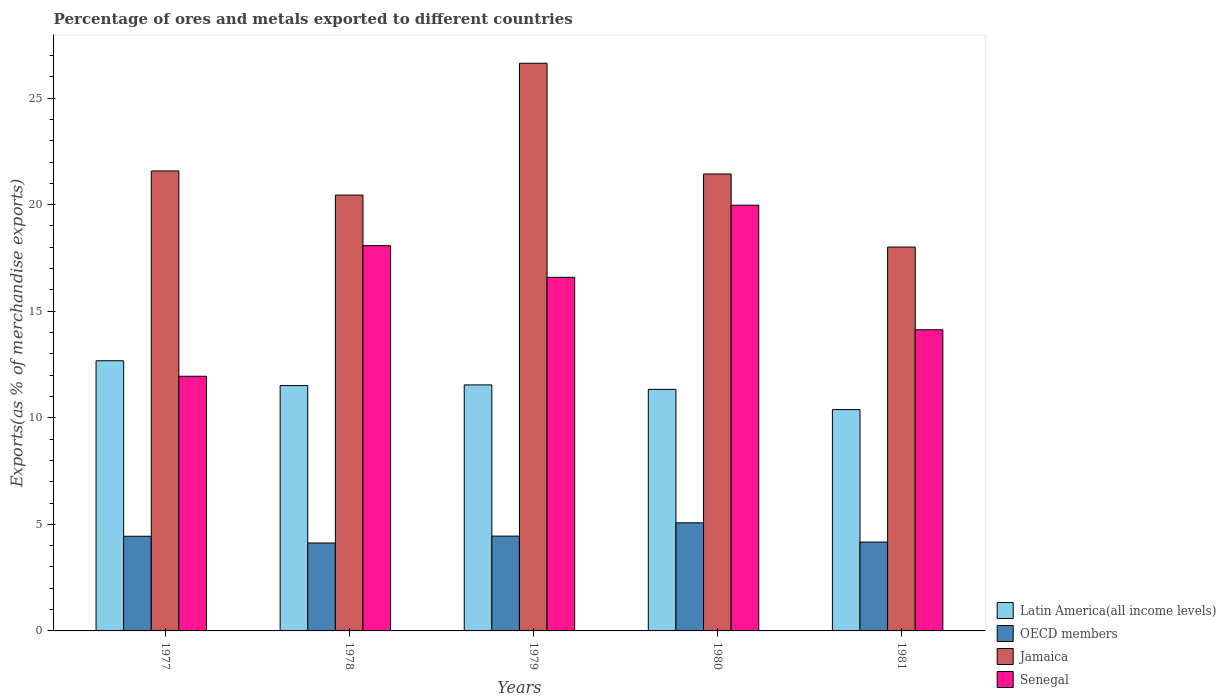Are the number of bars per tick equal to the number of legend labels?
Your response must be concise. Yes. What is the label of the 5th group of bars from the left?
Offer a terse response. 1981. In how many cases, is the number of bars for a given year not equal to the number of legend labels?
Provide a short and direct response. 0. What is the percentage of exports to different countries in Latin America(all income levels) in 1980?
Keep it short and to the point. 11.33. Across all years, what is the maximum percentage of exports to different countries in Senegal?
Your answer should be very brief. 19.97. Across all years, what is the minimum percentage of exports to different countries in Jamaica?
Keep it short and to the point. 18.01. In which year was the percentage of exports to different countries in Senegal maximum?
Your answer should be very brief. 1980. In which year was the percentage of exports to different countries in Senegal minimum?
Ensure brevity in your answer.  1977. What is the total percentage of exports to different countries in Latin America(all income levels) in the graph?
Give a very brief answer. 57.45. What is the difference between the percentage of exports to different countries in Senegal in 1977 and that in 1978?
Your answer should be very brief. -6.13. What is the difference between the percentage of exports to different countries in Jamaica in 1981 and the percentage of exports to different countries in Senegal in 1979?
Give a very brief answer. 1.42. What is the average percentage of exports to different countries in Jamaica per year?
Make the answer very short. 21.62. In the year 1978, what is the difference between the percentage of exports to different countries in Jamaica and percentage of exports to different countries in Senegal?
Offer a very short reply. 2.37. In how many years, is the percentage of exports to different countries in Latin America(all income levels) greater than 10 %?
Make the answer very short. 5. What is the ratio of the percentage of exports to different countries in Senegal in 1977 to that in 1980?
Your response must be concise. 0.6. What is the difference between the highest and the second highest percentage of exports to different countries in OECD members?
Give a very brief answer. 0.62. What is the difference between the highest and the lowest percentage of exports to different countries in Jamaica?
Keep it short and to the point. 8.62. Is it the case that in every year, the sum of the percentage of exports to different countries in Senegal and percentage of exports to different countries in OECD members is greater than the sum of percentage of exports to different countries in Latin America(all income levels) and percentage of exports to different countries in Jamaica?
Provide a short and direct response. No. What does the 1st bar from the left in 1979 represents?
Provide a short and direct response. Latin America(all income levels). What does the 4th bar from the right in 1980 represents?
Keep it short and to the point. Latin America(all income levels). How many bars are there?
Your answer should be compact. 20. Are all the bars in the graph horizontal?
Your answer should be compact. No. How many years are there in the graph?
Your answer should be compact. 5. Are the values on the major ticks of Y-axis written in scientific E-notation?
Give a very brief answer. No. Where does the legend appear in the graph?
Provide a short and direct response. Bottom right. How many legend labels are there?
Provide a succinct answer. 4. How are the legend labels stacked?
Make the answer very short. Vertical. What is the title of the graph?
Ensure brevity in your answer.  Percentage of ores and metals exported to different countries. What is the label or title of the X-axis?
Provide a short and direct response. Years. What is the label or title of the Y-axis?
Provide a short and direct response. Exports(as % of merchandise exports). What is the Exports(as % of merchandise exports) of Latin America(all income levels) in 1977?
Ensure brevity in your answer.  12.68. What is the Exports(as % of merchandise exports) of OECD members in 1977?
Make the answer very short. 4.44. What is the Exports(as % of merchandise exports) in Jamaica in 1977?
Keep it short and to the point. 21.58. What is the Exports(as % of merchandise exports) of Senegal in 1977?
Give a very brief answer. 11.95. What is the Exports(as % of merchandise exports) in Latin America(all income levels) in 1978?
Keep it short and to the point. 11.51. What is the Exports(as % of merchandise exports) in OECD members in 1978?
Give a very brief answer. 4.13. What is the Exports(as % of merchandise exports) in Jamaica in 1978?
Offer a terse response. 20.45. What is the Exports(as % of merchandise exports) of Senegal in 1978?
Your answer should be very brief. 18.08. What is the Exports(as % of merchandise exports) of Latin America(all income levels) in 1979?
Offer a very short reply. 11.54. What is the Exports(as % of merchandise exports) of OECD members in 1979?
Give a very brief answer. 4.45. What is the Exports(as % of merchandise exports) in Jamaica in 1979?
Offer a very short reply. 26.63. What is the Exports(as % of merchandise exports) of Senegal in 1979?
Your answer should be very brief. 16.59. What is the Exports(as % of merchandise exports) in Latin America(all income levels) in 1980?
Your response must be concise. 11.33. What is the Exports(as % of merchandise exports) of OECD members in 1980?
Ensure brevity in your answer.  5.07. What is the Exports(as % of merchandise exports) in Jamaica in 1980?
Provide a succinct answer. 21.44. What is the Exports(as % of merchandise exports) of Senegal in 1980?
Your response must be concise. 19.97. What is the Exports(as % of merchandise exports) in Latin America(all income levels) in 1981?
Make the answer very short. 10.38. What is the Exports(as % of merchandise exports) of OECD members in 1981?
Your response must be concise. 4.17. What is the Exports(as % of merchandise exports) in Jamaica in 1981?
Your response must be concise. 18.01. What is the Exports(as % of merchandise exports) in Senegal in 1981?
Offer a very short reply. 14.13. Across all years, what is the maximum Exports(as % of merchandise exports) in Latin America(all income levels)?
Make the answer very short. 12.68. Across all years, what is the maximum Exports(as % of merchandise exports) in OECD members?
Offer a very short reply. 5.07. Across all years, what is the maximum Exports(as % of merchandise exports) of Jamaica?
Offer a very short reply. 26.63. Across all years, what is the maximum Exports(as % of merchandise exports) of Senegal?
Your response must be concise. 19.97. Across all years, what is the minimum Exports(as % of merchandise exports) in Latin America(all income levels)?
Ensure brevity in your answer.  10.38. Across all years, what is the minimum Exports(as % of merchandise exports) of OECD members?
Make the answer very short. 4.13. Across all years, what is the minimum Exports(as % of merchandise exports) in Jamaica?
Offer a very short reply. 18.01. Across all years, what is the minimum Exports(as % of merchandise exports) in Senegal?
Your answer should be compact. 11.95. What is the total Exports(as % of merchandise exports) in Latin America(all income levels) in the graph?
Your answer should be very brief. 57.45. What is the total Exports(as % of merchandise exports) of OECD members in the graph?
Your answer should be very brief. 22.26. What is the total Exports(as % of merchandise exports) of Jamaica in the graph?
Your answer should be compact. 108.12. What is the total Exports(as % of merchandise exports) in Senegal in the graph?
Offer a very short reply. 80.72. What is the difference between the Exports(as % of merchandise exports) in Latin America(all income levels) in 1977 and that in 1978?
Keep it short and to the point. 1.16. What is the difference between the Exports(as % of merchandise exports) of OECD members in 1977 and that in 1978?
Keep it short and to the point. 0.32. What is the difference between the Exports(as % of merchandise exports) in Jamaica in 1977 and that in 1978?
Keep it short and to the point. 1.13. What is the difference between the Exports(as % of merchandise exports) of Senegal in 1977 and that in 1978?
Your answer should be compact. -6.13. What is the difference between the Exports(as % of merchandise exports) in Latin America(all income levels) in 1977 and that in 1979?
Ensure brevity in your answer.  1.13. What is the difference between the Exports(as % of merchandise exports) of OECD members in 1977 and that in 1979?
Your answer should be very brief. -0.01. What is the difference between the Exports(as % of merchandise exports) in Jamaica in 1977 and that in 1979?
Keep it short and to the point. -5.05. What is the difference between the Exports(as % of merchandise exports) of Senegal in 1977 and that in 1979?
Offer a terse response. -4.64. What is the difference between the Exports(as % of merchandise exports) in Latin America(all income levels) in 1977 and that in 1980?
Keep it short and to the point. 1.34. What is the difference between the Exports(as % of merchandise exports) of OECD members in 1977 and that in 1980?
Provide a succinct answer. -0.63. What is the difference between the Exports(as % of merchandise exports) in Jamaica in 1977 and that in 1980?
Provide a short and direct response. 0.14. What is the difference between the Exports(as % of merchandise exports) in Senegal in 1977 and that in 1980?
Ensure brevity in your answer.  -8.03. What is the difference between the Exports(as % of merchandise exports) in Latin America(all income levels) in 1977 and that in 1981?
Offer a terse response. 2.29. What is the difference between the Exports(as % of merchandise exports) in OECD members in 1977 and that in 1981?
Provide a short and direct response. 0.27. What is the difference between the Exports(as % of merchandise exports) in Jamaica in 1977 and that in 1981?
Give a very brief answer. 3.57. What is the difference between the Exports(as % of merchandise exports) of Senegal in 1977 and that in 1981?
Provide a succinct answer. -2.18. What is the difference between the Exports(as % of merchandise exports) in Latin America(all income levels) in 1978 and that in 1979?
Ensure brevity in your answer.  -0.03. What is the difference between the Exports(as % of merchandise exports) of OECD members in 1978 and that in 1979?
Offer a terse response. -0.32. What is the difference between the Exports(as % of merchandise exports) of Jamaica in 1978 and that in 1979?
Provide a succinct answer. -6.18. What is the difference between the Exports(as % of merchandise exports) of Senegal in 1978 and that in 1979?
Give a very brief answer. 1.49. What is the difference between the Exports(as % of merchandise exports) in Latin America(all income levels) in 1978 and that in 1980?
Ensure brevity in your answer.  0.18. What is the difference between the Exports(as % of merchandise exports) of OECD members in 1978 and that in 1980?
Your answer should be very brief. -0.95. What is the difference between the Exports(as % of merchandise exports) in Jamaica in 1978 and that in 1980?
Offer a terse response. -0.99. What is the difference between the Exports(as % of merchandise exports) in Senegal in 1978 and that in 1980?
Keep it short and to the point. -1.9. What is the difference between the Exports(as % of merchandise exports) of Latin America(all income levels) in 1978 and that in 1981?
Your answer should be compact. 1.13. What is the difference between the Exports(as % of merchandise exports) of OECD members in 1978 and that in 1981?
Provide a succinct answer. -0.04. What is the difference between the Exports(as % of merchandise exports) in Jamaica in 1978 and that in 1981?
Offer a terse response. 2.44. What is the difference between the Exports(as % of merchandise exports) in Senegal in 1978 and that in 1981?
Your response must be concise. 3.95. What is the difference between the Exports(as % of merchandise exports) of Latin America(all income levels) in 1979 and that in 1980?
Your answer should be very brief. 0.21. What is the difference between the Exports(as % of merchandise exports) of OECD members in 1979 and that in 1980?
Your response must be concise. -0.62. What is the difference between the Exports(as % of merchandise exports) of Jamaica in 1979 and that in 1980?
Your response must be concise. 5.2. What is the difference between the Exports(as % of merchandise exports) of Senegal in 1979 and that in 1980?
Make the answer very short. -3.38. What is the difference between the Exports(as % of merchandise exports) of Latin America(all income levels) in 1979 and that in 1981?
Your response must be concise. 1.16. What is the difference between the Exports(as % of merchandise exports) of OECD members in 1979 and that in 1981?
Ensure brevity in your answer.  0.28. What is the difference between the Exports(as % of merchandise exports) of Jamaica in 1979 and that in 1981?
Your response must be concise. 8.62. What is the difference between the Exports(as % of merchandise exports) in Senegal in 1979 and that in 1981?
Your answer should be very brief. 2.46. What is the difference between the Exports(as % of merchandise exports) in Latin America(all income levels) in 1980 and that in 1981?
Your answer should be very brief. 0.95. What is the difference between the Exports(as % of merchandise exports) of OECD members in 1980 and that in 1981?
Make the answer very short. 0.9. What is the difference between the Exports(as % of merchandise exports) of Jamaica in 1980 and that in 1981?
Offer a terse response. 3.43. What is the difference between the Exports(as % of merchandise exports) of Senegal in 1980 and that in 1981?
Your answer should be compact. 5.85. What is the difference between the Exports(as % of merchandise exports) in Latin America(all income levels) in 1977 and the Exports(as % of merchandise exports) in OECD members in 1978?
Offer a very short reply. 8.55. What is the difference between the Exports(as % of merchandise exports) of Latin America(all income levels) in 1977 and the Exports(as % of merchandise exports) of Jamaica in 1978?
Give a very brief answer. -7.77. What is the difference between the Exports(as % of merchandise exports) of Latin America(all income levels) in 1977 and the Exports(as % of merchandise exports) of Senegal in 1978?
Provide a succinct answer. -5.4. What is the difference between the Exports(as % of merchandise exports) in OECD members in 1977 and the Exports(as % of merchandise exports) in Jamaica in 1978?
Provide a succinct answer. -16.01. What is the difference between the Exports(as % of merchandise exports) of OECD members in 1977 and the Exports(as % of merchandise exports) of Senegal in 1978?
Your answer should be compact. -13.63. What is the difference between the Exports(as % of merchandise exports) of Jamaica in 1977 and the Exports(as % of merchandise exports) of Senegal in 1978?
Offer a very short reply. 3.51. What is the difference between the Exports(as % of merchandise exports) of Latin America(all income levels) in 1977 and the Exports(as % of merchandise exports) of OECD members in 1979?
Make the answer very short. 8.23. What is the difference between the Exports(as % of merchandise exports) of Latin America(all income levels) in 1977 and the Exports(as % of merchandise exports) of Jamaica in 1979?
Your answer should be very brief. -13.96. What is the difference between the Exports(as % of merchandise exports) in Latin America(all income levels) in 1977 and the Exports(as % of merchandise exports) in Senegal in 1979?
Provide a succinct answer. -3.91. What is the difference between the Exports(as % of merchandise exports) in OECD members in 1977 and the Exports(as % of merchandise exports) in Jamaica in 1979?
Make the answer very short. -22.19. What is the difference between the Exports(as % of merchandise exports) of OECD members in 1977 and the Exports(as % of merchandise exports) of Senegal in 1979?
Give a very brief answer. -12.15. What is the difference between the Exports(as % of merchandise exports) in Jamaica in 1977 and the Exports(as % of merchandise exports) in Senegal in 1979?
Your answer should be very brief. 4.99. What is the difference between the Exports(as % of merchandise exports) of Latin America(all income levels) in 1977 and the Exports(as % of merchandise exports) of OECD members in 1980?
Give a very brief answer. 7.6. What is the difference between the Exports(as % of merchandise exports) of Latin America(all income levels) in 1977 and the Exports(as % of merchandise exports) of Jamaica in 1980?
Provide a short and direct response. -8.76. What is the difference between the Exports(as % of merchandise exports) in Latin America(all income levels) in 1977 and the Exports(as % of merchandise exports) in Senegal in 1980?
Ensure brevity in your answer.  -7.3. What is the difference between the Exports(as % of merchandise exports) in OECD members in 1977 and the Exports(as % of merchandise exports) in Jamaica in 1980?
Keep it short and to the point. -17. What is the difference between the Exports(as % of merchandise exports) of OECD members in 1977 and the Exports(as % of merchandise exports) of Senegal in 1980?
Make the answer very short. -15.53. What is the difference between the Exports(as % of merchandise exports) of Jamaica in 1977 and the Exports(as % of merchandise exports) of Senegal in 1980?
Provide a succinct answer. 1.61. What is the difference between the Exports(as % of merchandise exports) in Latin America(all income levels) in 1977 and the Exports(as % of merchandise exports) in OECD members in 1981?
Offer a terse response. 8.51. What is the difference between the Exports(as % of merchandise exports) in Latin America(all income levels) in 1977 and the Exports(as % of merchandise exports) in Jamaica in 1981?
Provide a succinct answer. -5.33. What is the difference between the Exports(as % of merchandise exports) of Latin America(all income levels) in 1977 and the Exports(as % of merchandise exports) of Senegal in 1981?
Your answer should be very brief. -1.45. What is the difference between the Exports(as % of merchandise exports) of OECD members in 1977 and the Exports(as % of merchandise exports) of Jamaica in 1981?
Keep it short and to the point. -13.57. What is the difference between the Exports(as % of merchandise exports) in OECD members in 1977 and the Exports(as % of merchandise exports) in Senegal in 1981?
Make the answer very short. -9.69. What is the difference between the Exports(as % of merchandise exports) of Jamaica in 1977 and the Exports(as % of merchandise exports) of Senegal in 1981?
Keep it short and to the point. 7.45. What is the difference between the Exports(as % of merchandise exports) in Latin America(all income levels) in 1978 and the Exports(as % of merchandise exports) in OECD members in 1979?
Your answer should be very brief. 7.06. What is the difference between the Exports(as % of merchandise exports) in Latin America(all income levels) in 1978 and the Exports(as % of merchandise exports) in Jamaica in 1979?
Keep it short and to the point. -15.12. What is the difference between the Exports(as % of merchandise exports) in Latin America(all income levels) in 1978 and the Exports(as % of merchandise exports) in Senegal in 1979?
Offer a terse response. -5.08. What is the difference between the Exports(as % of merchandise exports) in OECD members in 1978 and the Exports(as % of merchandise exports) in Jamaica in 1979?
Provide a succinct answer. -22.51. What is the difference between the Exports(as % of merchandise exports) in OECD members in 1978 and the Exports(as % of merchandise exports) in Senegal in 1979?
Ensure brevity in your answer.  -12.46. What is the difference between the Exports(as % of merchandise exports) of Jamaica in 1978 and the Exports(as % of merchandise exports) of Senegal in 1979?
Provide a short and direct response. 3.86. What is the difference between the Exports(as % of merchandise exports) of Latin America(all income levels) in 1978 and the Exports(as % of merchandise exports) of OECD members in 1980?
Offer a terse response. 6.44. What is the difference between the Exports(as % of merchandise exports) in Latin America(all income levels) in 1978 and the Exports(as % of merchandise exports) in Jamaica in 1980?
Provide a succinct answer. -9.93. What is the difference between the Exports(as % of merchandise exports) of Latin America(all income levels) in 1978 and the Exports(as % of merchandise exports) of Senegal in 1980?
Provide a short and direct response. -8.46. What is the difference between the Exports(as % of merchandise exports) of OECD members in 1978 and the Exports(as % of merchandise exports) of Jamaica in 1980?
Offer a terse response. -17.31. What is the difference between the Exports(as % of merchandise exports) in OECD members in 1978 and the Exports(as % of merchandise exports) in Senegal in 1980?
Keep it short and to the point. -15.85. What is the difference between the Exports(as % of merchandise exports) in Jamaica in 1978 and the Exports(as % of merchandise exports) in Senegal in 1980?
Give a very brief answer. 0.48. What is the difference between the Exports(as % of merchandise exports) of Latin America(all income levels) in 1978 and the Exports(as % of merchandise exports) of OECD members in 1981?
Your response must be concise. 7.34. What is the difference between the Exports(as % of merchandise exports) of Latin America(all income levels) in 1978 and the Exports(as % of merchandise exports) of Jamaica in 1981?
Make the answer very short. -6.5. What is the difference between the Exports(as % of merchandise exports) of Latin America(all income levels) in 1978 and the Exports(as % of merchandise exports) of Senegal in 1981?
Make the answer very short. -2.62. What is the difference between the Exports(as % of merchandise exports) in OECD members in 1978 and the Exports(as % of merchandise exports) in Jamaica in 1981?
Offer a very short reply. -13.88. What is the difference between the Exports(as % of merchandise exports) of OECD members in 1978 and the Exports(as % of merchandise exports) of Senegal in 1981?
Your response must be concise. -10. What is the difference between the Exports(as % of merchandise exports) of Jamaica in 1978 and the Exports(as % of merchandise exports) of Senegal in 1981?
Keep it short and to the point. 6.32. What is the difference between the Exports(as % of merchandise exports) of Latin America(all income levels) in 1979 and the Exports(as % of merchandise exports) of OECD members in 1980?
Make the answer very short. 6.47. What is the difference between the Exports(as % of merchandise exports) in Latin America(all income levels) in 1979 and the Exports(as % of merchandise exports) in Jamaica in 1980?
Keep it short and to the point. -9.89. What is the difference between the Exports(as % of merchandise exports) in Latin America(all income levels) in 1979 and the Exports(as % of merchandise exports) in Senegal in 1980?
Offer a terse response. -8.43. What is the difference between the Exports(as % of merchandise exports) in OECD members in 1979 and the Exports(as % of merchandise exports) in Jamaica in 1980?
Your answer should be compact. -16.99. What is the difference between the Exports(as % of merchandise exports) in OECD members in 1979 and the Exports(as % of merchandise exports) in Senegal in 1980?
Your answer should be compact. -15.53. What is the difference between the Exports(as % of merchandise exports) in Jamaica in 1979 and the Exports(as % of merchandise exports) in Senegal in 1980?
Your answer should be compact. 6.66. What is the difference between the Exports(as % of merchandise exports) of Latin America(all income levels) in 1979 and the Exports(as % of merchandise exports) of OECD members in 1981?
Make the answer very short. 7.37. What is the difference between the Exports(as % of merchandise exports) in Latin America(all income levels) in 1979 and the Exports(as % of merchandise exports) in Jamaica in 1981?
Provide a short and direct response. -6.47. What is the difference between the Exports(as % of merchandise exports) in Latin America(all income levels) in 1979 and the Exports(as % of merchandise exports) in Senegal in 1981?
Keep it short and to the point. -2.59. What is the difference between the Exports(as % of merchandise exports) of OECD members in 1979 and the Exports(as % of merchandise exports) of Jamaica in 1981?
Provide a short and direct response. -13.56. What is the difference between the Exports(as % of merchandise exports) of OECD members in 1979 and the Exports(as % of merchandise exports) of Senegal in 1981?
Provide a succinct answer. -9.68. What is the difference between the Exports(as % of merchandise exports) of Jamaica in 1979 and the Exports(as % of merchandise exports) of Senegal in 1981?
Keep it short and to the point. 12.5. What is the difference between the Exports(as % of merchandise exports) in Latin America(all income levels) in 1980 and the Exports(as % of merchandise exports) in OECD members in 1981?
Your answer should be very brief. 7.16. What is the difference between the Exports(as % of merchandise exports) of Latin America(all income levels) in 1980 and the Exports(as % of merchandise exports) of Jamaica in 1981?
Provide a succinct answer. -6.68. What is the difference between the Exports(as % of merchandise exports) of Latin America(all income levels) in 1980 and the Exports(as % of merchandise exports) of Senegal in 1981?
Keep it short and to the point. -2.8. What is the difference between the Exports(as % of merchandise exports) in OECD members in 1980 and the Exports(as % of merchandise exports) in Jamaica in 1981?
Offer a terse response. -12.94. What is the difference between the Exports(as % of merchandise exports) of OECD members in 1980 and the Exports(as % of merchandise exports) of Senegal in 1981?
Keep it short and to the point. -9.06. What is the difference between the Exports(as % of merchandise exports) in Jamaica in 1980 and the Exports(as % of merchandise exports) in Senegal in 1981?
Offer a terse response. 7.31. What is the average Exports(as % of merchandise exports) of Latin America(all income levels) per year?
Provide a succinct answer. 11.49. What is the average Exports(as % of merchandise exports) in OECD members per year?
Keep it short and to the point. 4.45. What is the average Exports(as % of merchandise exports) of Jamaica per year?
Your answer should be very brief. 21.62. What is the average Exports(as % of merchandise exports) in Senegal per year?
Your answer should be compact. 16.14. In the year 1977, what is the difference between the Exports(as % of merchandise exports) in Latin America(all income levels) and Exports(as % of merchandise exports) in OECD members?
Your answer should be very brief. 8.23. In the year 1977, what is the difference between the Exports(as % of merchandise exports) in Latin America(all income levels) and Exports(as % of merchandise exports) in Jamaica?
Offer a terse response. -8.91. In the year 1977, what is the difference between the Exports(as % of merchandise exports) of Latin America(all income levels) and Exports(as % of merchandise exports) of Senegal?
Ensure brevity in your answer.  0.73. In the year 1977, what is the difference between the Exports(as % of merchandise exports) of OECD members and Exports(as % of merchandise exports) of Jamaica?
Keep it short and to the point. -17.14. In the year 1977, what is the difference between the Exports(as % of merchandise exports) of OECD members and Exports(as % of merchandise exports) of Senegal?
Your answer should be very brief. -7.51. In the year 1977, what is the difference between the Exports(as % of merchandise exports) of Jamaica and Exports(as % of merchandise exports) of Senegal?
Ensure brevity in your answer.  9.63. In the year 1978, what is the difference between the Exports(as % of merchandise exports) in Latin America(all income levels) and Exports(as % of merchandise exports) in OECD members?
Your answer should be compact. 7.39. In the year 1978, what is the difference between the Exports(as % of merchandise exports) in Latin America(all income levels) and Exports(as % of merchandise exports) in Jamaica?
Offer a terse response. -8.94. In the year 1978, what is the difference between the Exports(as % of merchandise exports) in Latin America(all income levels) and Exports(as % of merchandise exports) in Senegal?
Ensure brevity in your answer.  -6.56. In the year 1978, what is the difference between the Exports(as % of merchandise exports) of OECD members and Exports(as % of merchandise exports) of Jamaica?
Provide a short and direct response. -16.32. In the year 1978, what is the difference between the Exports(as % of merchandise exports) of OECD members and Exports(as % of merchandise exports) of Senegal?
Provide a short and direct response. -13.95. In the year 1978, what is the difference between the Exports(as % of merchandise exports) in Jamaica and Exports(as % of merchandise exports) in Senegal?
Make the answer very short. 2.37. In the year 1979, what is the difference between the Exports(as % of merchandise exports) of Latin America(all income levels) and Exports(as % of merchandise exports) of OECD members?
Provide a short and direct response. 7.09. In the year 1979, what is the difference between the Exports(as % of merchandise exports) in Latin America(all income levels) and Exports(as % of merchandise exports) in Jamaica?
Your answer should be very brief. -15.09. In the year 1979, what is the difference between the Exports(as % of merchandise exports) in Latin America(all income levels) and Exports(as % of merchandise exports) in Senegal?
Provide a short and direct response. -5.05. In the year 1979, what is the difference between the Exports(as % of merchandise exports) in OECD members and Exports(as % of merchandise exports) in Jamaica?
Give a very brief answer. -22.19. In the year 1979, what is the difference between the Exports(as % of merchandise exports) in OECD members and Exports(as % of merchandise exports) in Senegal?
Provide a succinct answer. -12.14. In the year 1979, what is the difference between the Exports(as % of merchandise exports) in Jamaica and Exports(as % of merchandise exports) in Senegal?
Your answer should be very brief. 10.04. In the year 1980, what is the difference between the Exports(as % of merchandise exports) in Latin America(all income levels) and Exports(as % of merchandise exports) in OECD members?
Make the answer very short. 6.26. In the year 1980, what is the difference between the Exports(as % of merchandise exports) of Latin America(all income levels) and Exports(as % of merchandise exports) of Jamaica?
Provide a succinct answer. -10.1. In the year 1980, what is the difference between the Exports(as % of merchandise exports) in Latin America(all income levels) and Exports(as % of merchandise exports) in Senegal?
Offer a terse response. -8.64. In the year 1980, what is the difference between the Exports(as % of merchandise exports) of OECD members and Exports(as % of merchandise exports) of Jamaica?
Ensure brevity in your answer.  -16.37. In the year 1980, what is the difference between the Exports(as % of merchandise exports) in OECD members and Exports(as % of merchandise exports) in Senegal?
Keep it short and to the point. -14.9. In the year 1980, what is the difference between the Exports(as % of merchandise exports) in Jamaica and Exports(as % of merchandise exports) in Senegal?
Keep it short and to the point. 1.46. In the year 1981, what is the difference between the Exports(as % of merchandise exports) in Latin America(all income levels) and Exports(as % of merchandise exports) in OECD members?
Provide a short and direct response. 6.22. In the year 1981, what is the difference between the Exports(as % of merchandise exports) in Latin America(all income levels) and Exports(as % of merchandise exports) in Jamaica?
Make the answer very short. -7.63. In the year 1981, what is the difference between the Exports(as % of merchandise exports) of Latin America(all income levels) and Exports(as % of merchandise exports) of Senegal?
Provide a succinct answer. -3.75. In the year 1981, what is the difference between the Exports(as % of merchandise exports) in OECD members and Exports(as % of merchandise exports) in Jamaica?
Provide a succinct answer. -13.84. In the year 1981, what is the difference between the Exports(as % of merchandise exports) in OECD members and Exports(as % of merchandise exports) in Senegal?
Offer a very short reply. -9.96. In the year 1981, what is the difference between the Exports(as % of merchandise exports) in Jamaica and Exports(as % of merchandise exports) in Senegal?
Provide a short and direct response. 3.88. What is the ratio of the Exports(as % of merchandise exports) of Latin America(all income levels) in 1977 to that in 1978?
Ensure brevity in your answer.  1.1. What is the ratio of the Exports(as % of merchandise exports) of OECD members in 1977 to that in 1978?
Your answer should be compact. 1.08. What is the ratio of the Exports(as % of merchandise exports) in Jamaica in 1977 to that in 1978?
Your response must be concise. 1.06. What is the ratio of the Exports(as % of merchandise exports) in Senegal in 1977 to that in 1978?
Give a very brief answer. 0.66. What is the ratio of the Exports(as % of merchandise exports) of Latin America(all income levels) in 1977 to that in 1979?
Offer a very short reply. 1.1. What is the ratio of the Exports(as % of merchandise exports) of Jamaica in 1977 to that in 1979?
Offer a terse response. 0.81. What is the ratio of the Exports(as % of merchandise exports) of Senegal in 1977 to that in 1979?
Ensure brevity in your answer.  0.72. What is the ratio of the Exports(as % of merchandise exports) of Latin America(all income levels) in 1977 to that in 1980?
Your response must be concise. 1.12. What is the ratio of the Exports(as % of merchandise exports) in OECD members in 1977 to that in 1980?
Offer a very short reply. 0.88. What is the ratio of the Exports(as % of merchandise exports) of Senegal in 1977 to that in 1980?
Offer a very short reply. 0.6. What is the ratio of the Exports(as % of merchandise exports) of Latin America(all income levels) in 1977 to that in 1981?
Offer a very short reply. 1.22. What is the ratio of the Exports(as % of merchandise exports) in OECD members in 1977 to that in 1981?
Your response must be concise. 1.07. What is the ratio of the Exports(as % of merchandise exports) of Jamaica in 1977 to that in 1981?
Offer a very short reply. 1.2. What is the ratio of the Exports(as % of merchandise exports) in Senegal in 1977 to that in 1981?
Provide a succinct answer. 0.85. What is the ratio of the Exports(as % of merchandise exports) of OECD members in 1978 to that in 1979?
Your answer should be very brief. 0.93. What is the ratio of the Exports(as % of merchandise exports) in Jamaica in 1978 to that in 1979?
Your answer should be compact. 0.77. What is the ratio of the Exports(as % of merchandise exports) in Senegal in 1978 to that in 1979?
Ensure brevity in your answer.  1.09. What is the ratio of the Exports(as % of merchandise exports) in Latin America(all income levels) in 1978 to that in 1980?
Provide a short and direct response. 1.02. What is the ratio of the Exports(as % of merchandise exports) in OECD members in 1978 to that in 1980?
Your answer should be compact. 0.81. What is the ratio of the Exports(as % of merchandise exports) of Jamaica in 1978 to that in 1980?
Give a very brief answer. 0.95. What is the ratio of the Exports(as % of merchandise exports) of Senegal in 1978 to that in 1980?
Give a very brief answer. 0.9. What is the ratio of the Exports(as % of merchandise exports) of Latin America(all income levels) in 1978 to that in 1981?
Offer a very short reply. 1.11. What is the ratio of the Exports(as % of merchandise exports) of Jamaica in 1978 to that in 1981?
Your answer should be compact. 1.14. What is the ratio of the Exports(as % of merchandise exports) in Senegal in 1978 to that in 1981?
Offer a terse response. 1.28. What is the ratio of the Exports(as % of merchandise exports) in Latin America(all income levels) in 1979 to that in 1980?
Your answer should be very brief. 1.02. What is the ratio of the Exports(as % of merchandise exports) in OECD members in 1979 to that in 1980?
Offer a terse response. 0.88. What is the ratio of the Exports(as % of merchandise exports) in Jamaica in 1979 to that in 1980?
Provide a short and direct response. 1.24. What is the ratio of the Exports(as % of merchandise exports) in Senegal in 1979 to that in 1980?
Ensure brevity in your answer.  0.83. What is the ratio of the Exports(as % of merchandise exports) in Latin America(all income levels) in 1979 to that in 1981?
Provide a short and direct response. 1.11. What is the ratio of the Exports(as % of merchandise exports) of OECD members in 1979 to that in 1981?
Your answer should be very brief. 1.07. What is the ratio of the Exports(as % of merchandise exports) in Jamaica in 1979 to that in 1981?
Give a very brief answer. 1.48. What is the ratio of the Exports(as % of merchandise exports) in Senegal in 1979 to that in 1981?
Provide a short and direct response. 1.17. What is the ratio of the Exports(as % of merchandise exports) in Latin America(all income levels) in 1980 to that in 1981?
Offer a terse response. 1.09. What is the ratio of the Exports(as % of merchandise exports) of OECD members in 1980 to that in 1981?
Offer a terse response. 1.22. What is the ratio of the Exports(as % of merchandise exports) in Jamaica in 1980 to that in 1981?
Make the answer very short. 1.19. What is the ratio of the Exports(as % of merchandise exports) in Senegal in 1980 to that in 1981?
Your answer should be very brief. 1.41. What is the difference between the highest and the second highest Exports(as % of merchandise exports) in Latin America(all income levels)?
Provide a succinct answer. 1.13. What is the difference between the highest and the second highest Exports(as % of merchandise exports) of OECD members?
Your response must be concise. 0.62. What is the difference between the highest and the second highest Exports(as % of merchandise exports) in Jamaica?
Offer a very short reply. 5.05. What is the difference between the highest and the second highest Exports(as % of merchandise exports) of Senegal?
Give a very brief answer. 1.9. What is the difference between the highest and the lowest Exports(as % of merchandise exports) in Latin America(all income levels)?
Your response must be concise. 2.29. What is the difference between the highest and the lowest Exports(as % of merchandise exports) in OECD members?
Keep it short and to the point. 0.95. What is the difference between the highest and the lowest Exports(as % of merchandise exports) in Jamaica?
Your response must be concise. 8.62. What is the difference between the highest and the lowest Exports(as % of merchandise exports) in Senegal?
Offer a terse response. 8.03. 